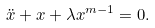<formula> <loc_0><loc_0><loc_500><loc_500>\ddot { x } + x + \lambda x ^ { m - 1 } = 0 .</formula> 